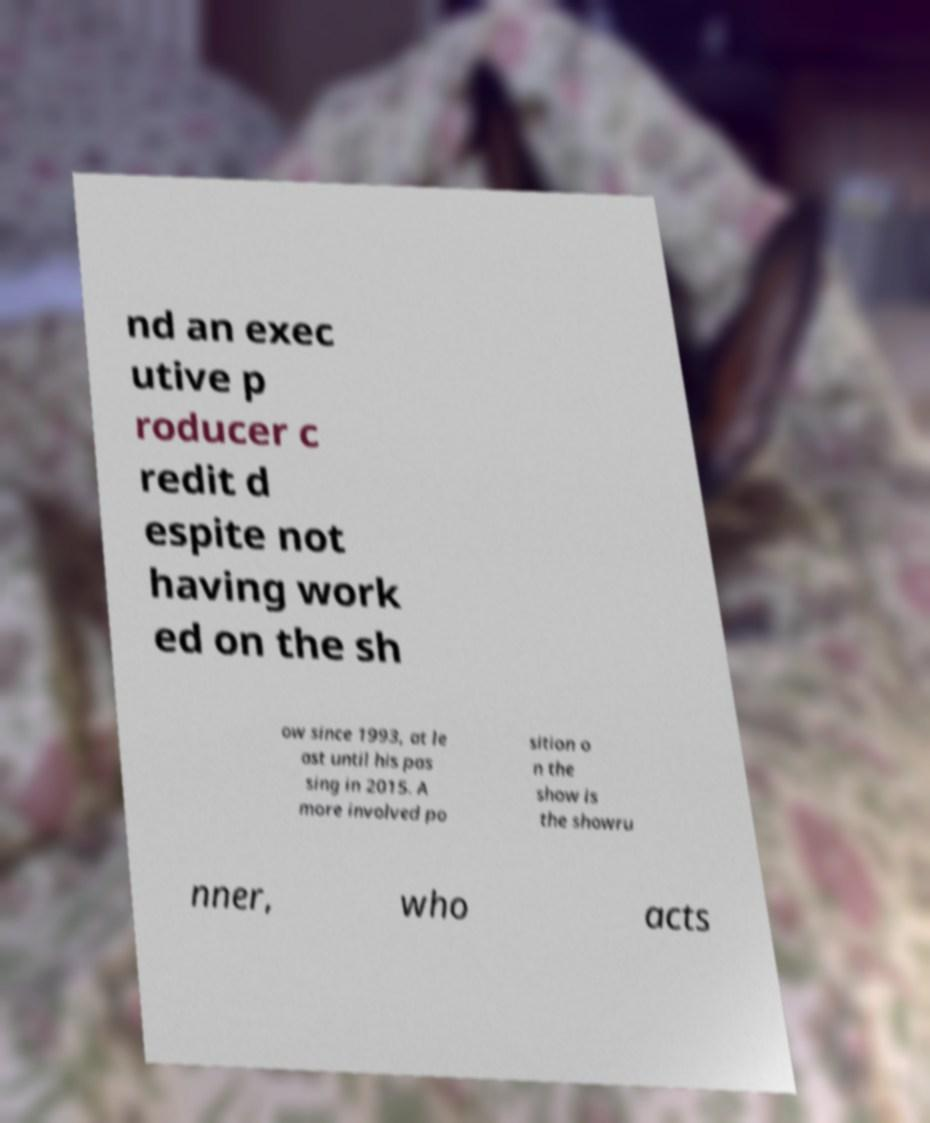Can you accurately transcribe the text from the provided image for me? nd an exec utive p roducer c redit d espite not having work ed on the sh ow since 1993, at le ast until his pas sing in 2015. A more involved po sition o n the show is the showru nner, who acts 